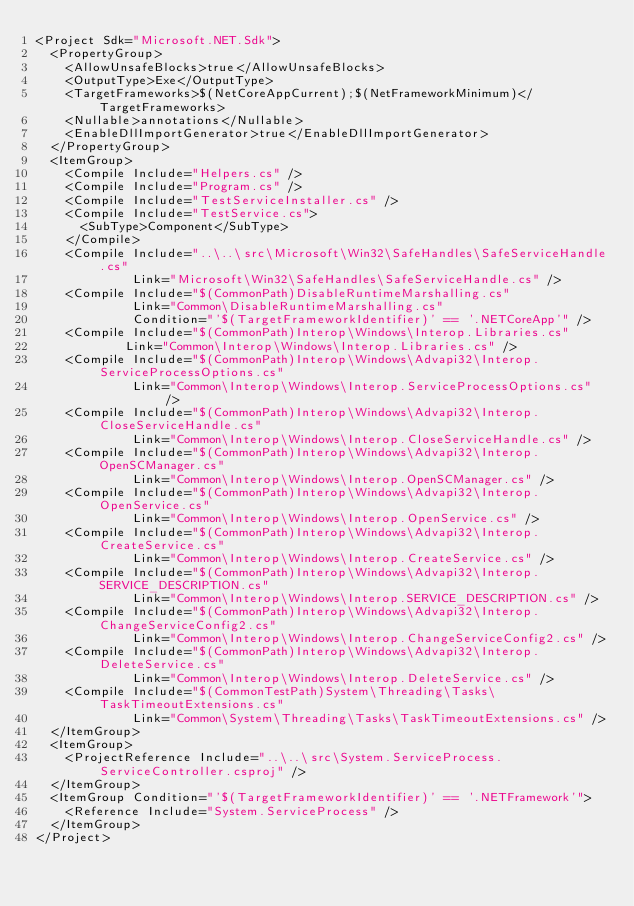Convert code to text. <code><loc_0><loc_0><loc_500><loc_500><_XML_><Project Sdk="Microsoft.NET.Sdk">
  <PropertyGroup>
    <AllowUnsafeBlocks>true</AllowUnsafeBlocks>
    <OutputType>Exe</OutputType>
    <TargetFrameworks>$(NetCoreAppCurrent);$(NetFrameworkMinimum)</TargetFrameworks>
    <Nullable>annotations</Nullable>
    <EnableDllImportGenerator>true</EnableDllImportGenerator>
  </PropertyGroup>
  <ItemGroup>
    <Compile Include="Helpers.cs" />
    <Compile Include="Program.cs" />
    <Compile Include="TestServiceInstaller.cs" />
    <Compile Include="TestService.cs">
      <SubType>Component</SubType>
    </Compile>
    <Compile Include="..\..\src\Microsoft\Win32\SafeHandles\SafeServiceHandle.cs"
             Link="Microsoft\Win32\SafeHandles\SafeServiceHandle.cs" />
    <Compile Include="$(CommonPath)DisableRuntimeMarshalling.cs"
             Link="Common\DisableRuntimeMarshalling.cs"
             Condition="'$(TargetFrameworkIdentifier)' == '.NETCoreApp'" />
    <Compile Include="$(CommonPath)Interop\Windows\Interop.Libraries.cs"
            Link="Common\Interop\Windows\Interop.Libraries.cs" />
    <Compile Include="$(CommonPath)Interop\Windows\Advapi32\Interop.ServiceProcessOptions.cs"
             Link="Common\Interop\Windows\Interop.ServiceProcessOptions.cs" />
    <Compile Include="$(CommonPath)Interop\Windows\Advapi32\Interop.CloseServiceHandle.cs"
             Link="Common\Interop\Windows\Interop.CloseServiceHandle.cs" />
    <Compile Include="$(CommonPath)Interop\Windows\Advapi32\Interop.OpenSCManager.cs"
             Link="Common\Interop\Windows\Interop.OpenSCManager.cs" />
    <Compile Include="$(CommonPath)Interop\Windows\Advapi32\Interop.OpenService.cs"
             Link="Common\Interop\Windows\Interop.OpenService.cs" />
    <Compile Include="$(CommonPath)Interop\Windows\Advapi32\Interop.CreateService.cs"
             Link="Common\Interop\Windows\Interop.CreateService.cs" />
    <Compile Include="$(CommonPath)Interop\Windows\Advapi32\Interop.SERVICE_DESCRIPTION.cs"
             Link="Common\Interop\Windows\Interop.SERVICE_DESCRIPTION.cs" />
    <Compile Include="$(CommonPath)Interop\Windows\Advapi32\Interop.ChangeServiceConfig2.cs"
             Link="Common\Interop\Windows\Interop.ChangeServiceConfig2.cs" />
    <Compile Include="$(CommonPath)Interop\Windows\Advapi32\Interop.DeleteService.cs"
             Link="Common\Interop\Windows\Interop.DeleteService.cs" />
    <Compile Include="$(CommonTestPath)System\Threading\Tasks\TaskTimeoutExtensions.cs"
             Link="Common\System\Threading\Tasks\TaskTimeoutExtensions.cs" />
  </ItemGroup>
  <ItemGroup>
    <ProjectReference Include="..\..\src\System.ServiceProcess.ServiceController.csproj" />
  </ItemGroup>
  <ItemGroup Condition="'$(TargetFrameworkIdentifier)' == '.NETFramework'">
    <Reference Include="System.ServiceProcess" />
  </ItemGroup>
</Project>
</code> 